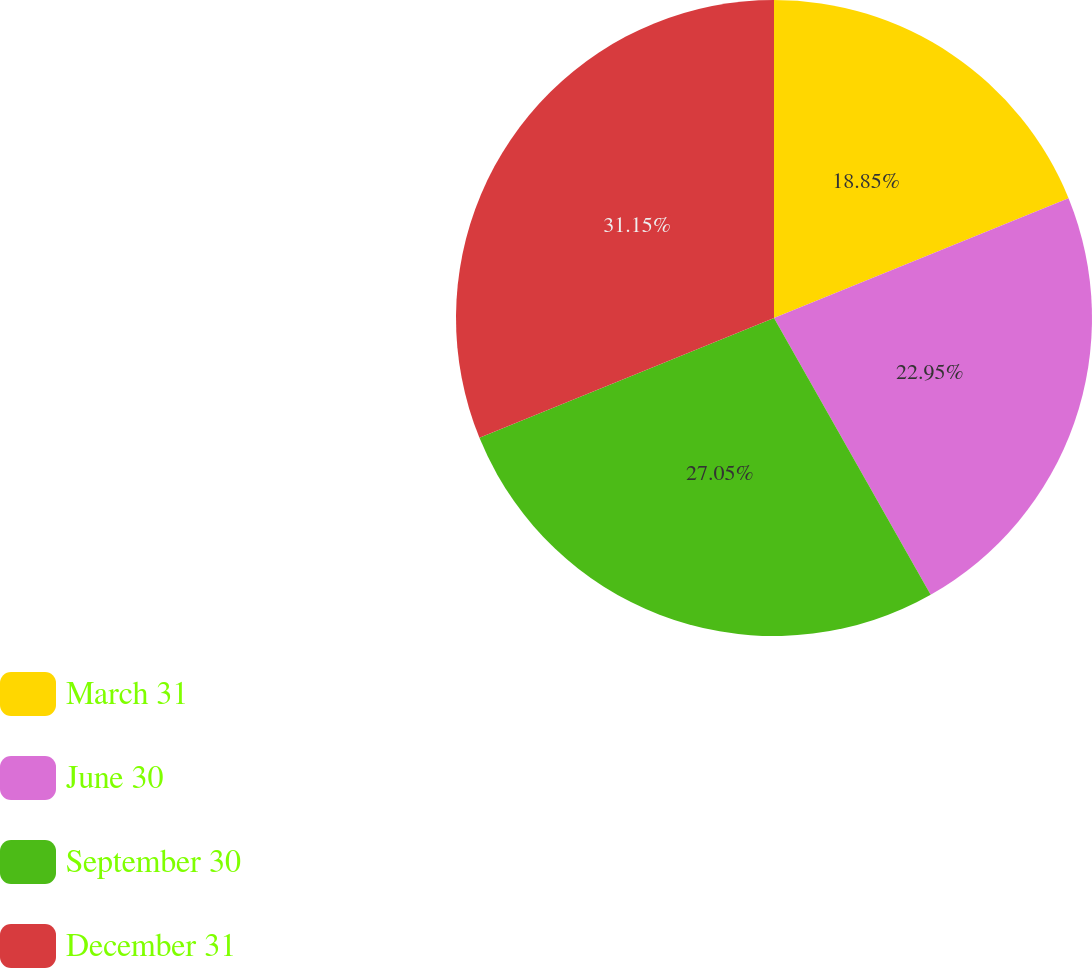<chart> <loc_0><loc_0><loc_500><loc_500><pie_chart><fcel>March 31<fcel>June 30<fcel>September 30<fcel>December 31<nl><fcel>18.85%<fcel>22.95%<fcel>27.05%<fcel>31.15%<nl></chart> 